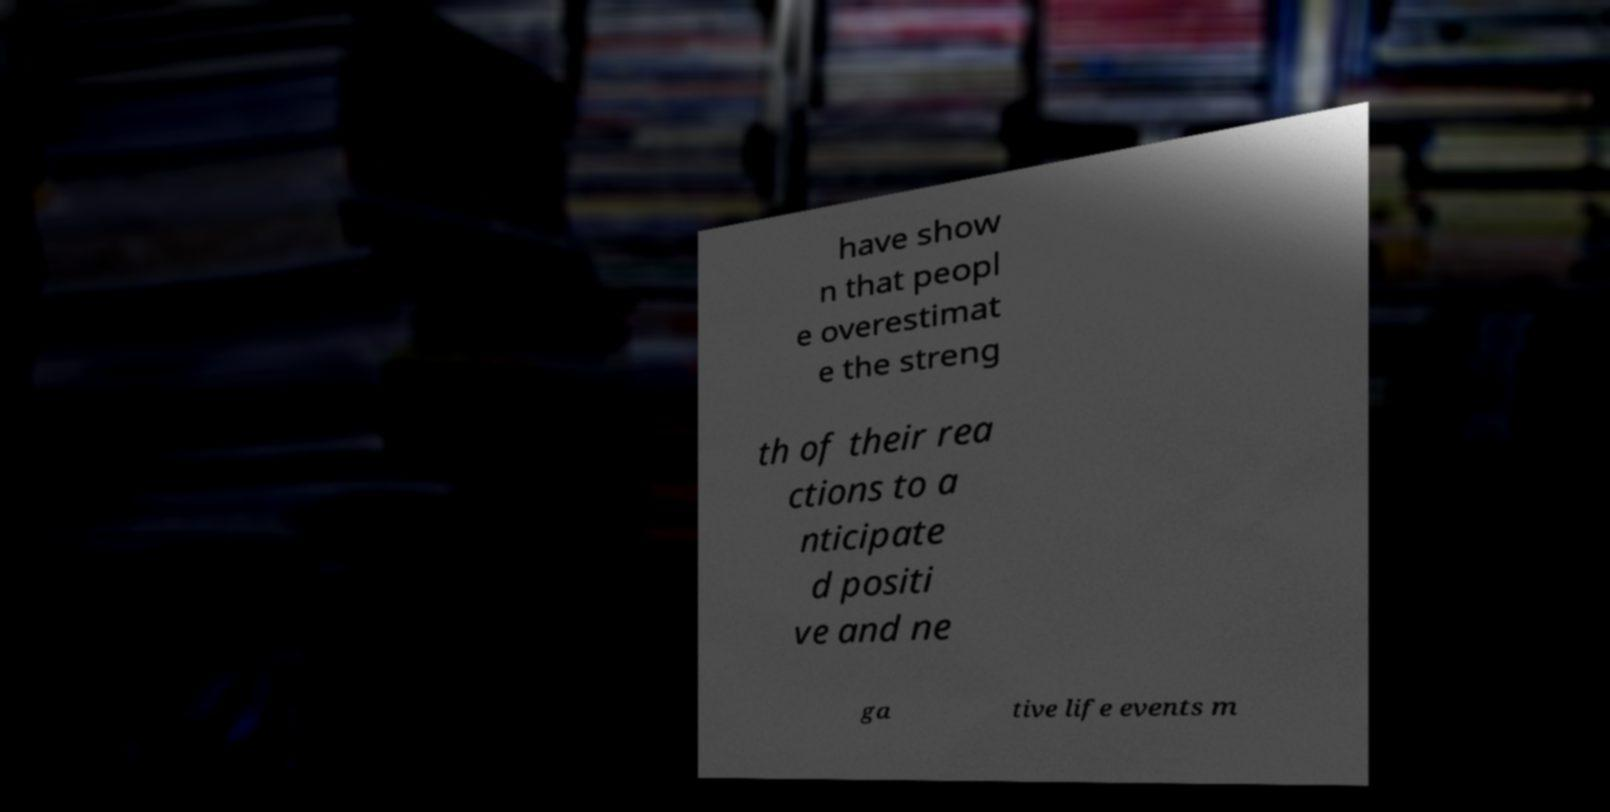Could you extract and type out the text from this image? have show n that peopl e overestimat e the streng th of their rea ctions to a nticipate d positi ve and ne ga tive life events m 